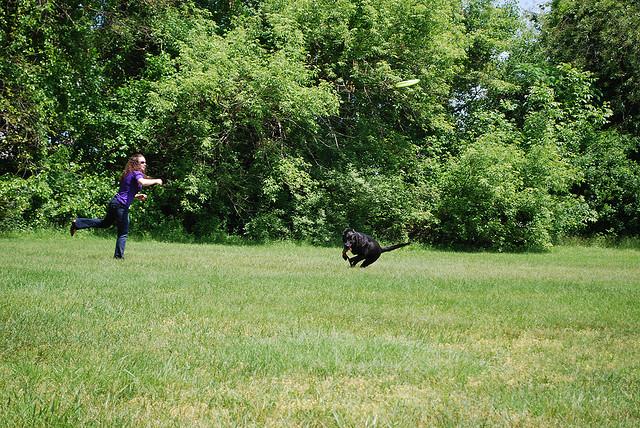What animal is that?
Quick response, please. Dog. What did the woman throw to the dog?
Concise answer only. Frisbee. What kind of animal is in the middle of the picture?
Quick response, please. Dog. What color is the grass?
Keep it brief. Green. What is the dog holding?
Keep it brief. Nothing. 